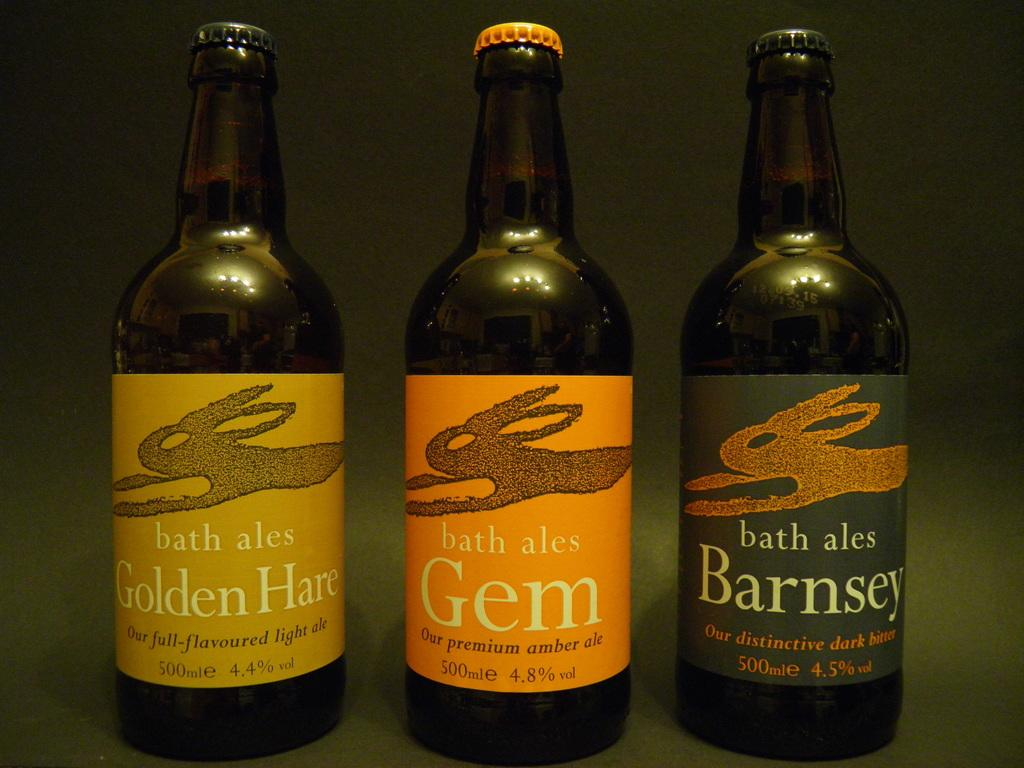<image>
Offer a succinct explanation of the picture presented. Three bottles of bath ales sit next to each other on a green surface 